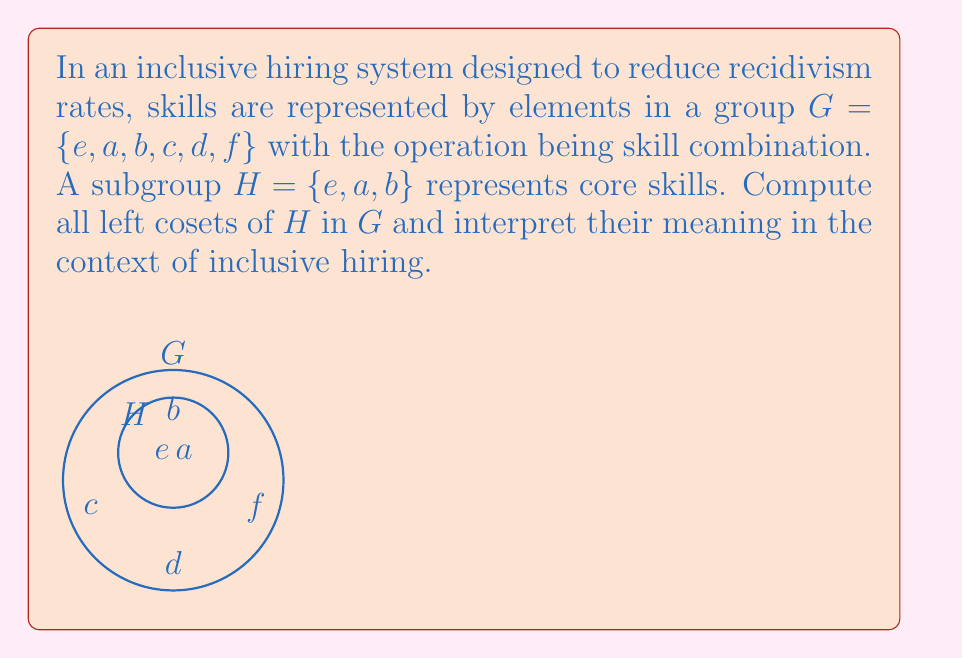Help me with this question. Let's approach this step-by-step:

1) To find left cosets, we multiply each element of $G$ by $H$ from the left.

2) The left cosets are of the form $gH = \{gh : h \in H\}$ for each $g \in G$.

3) Let's compute each coset:

   a) $eH = \{eh : h \in H\} = \{e, a, b\} = H$
   b) $aH = \{ah : h \in H\} = \{a, a^2, ab\} = \{a, e, b\} = H$
   c) $bH = \{bh : h \in H\} = \{b, ba, b^2\} = \{b, a, e\} = H$
   d) $cH = \{ch : h \in H\} = \{c, ca, cb\}$
   e) $dH = \{dh : h \in H\} = \{d, da, db\}$
   f) $fH = \{fh : h \in H\} = \{f, fa, fb\}$

4) We observe that $eH = aH = bH = H$, while $cH$, $dH$, and $fH$ are distinct.

5) Therefore, the distinct left cosets are: $H$, $cH$, $dH$, and $fH$.

Interpretation in inclusive hiring:
- $H$ represents candidates with core skills.
- $cH$, $dH$, and $fH$ represent candidates with additional skills beyond the core set.
- This coset structure suggests that the hiring system recognizes both core competencies and diverse skill sets, promoting inclusivity and potentially reducing recidivism by considering a wider range of candidates.
Answer: The distinct left cosets are $H$, $cH$, $dH$, and $fH$. 